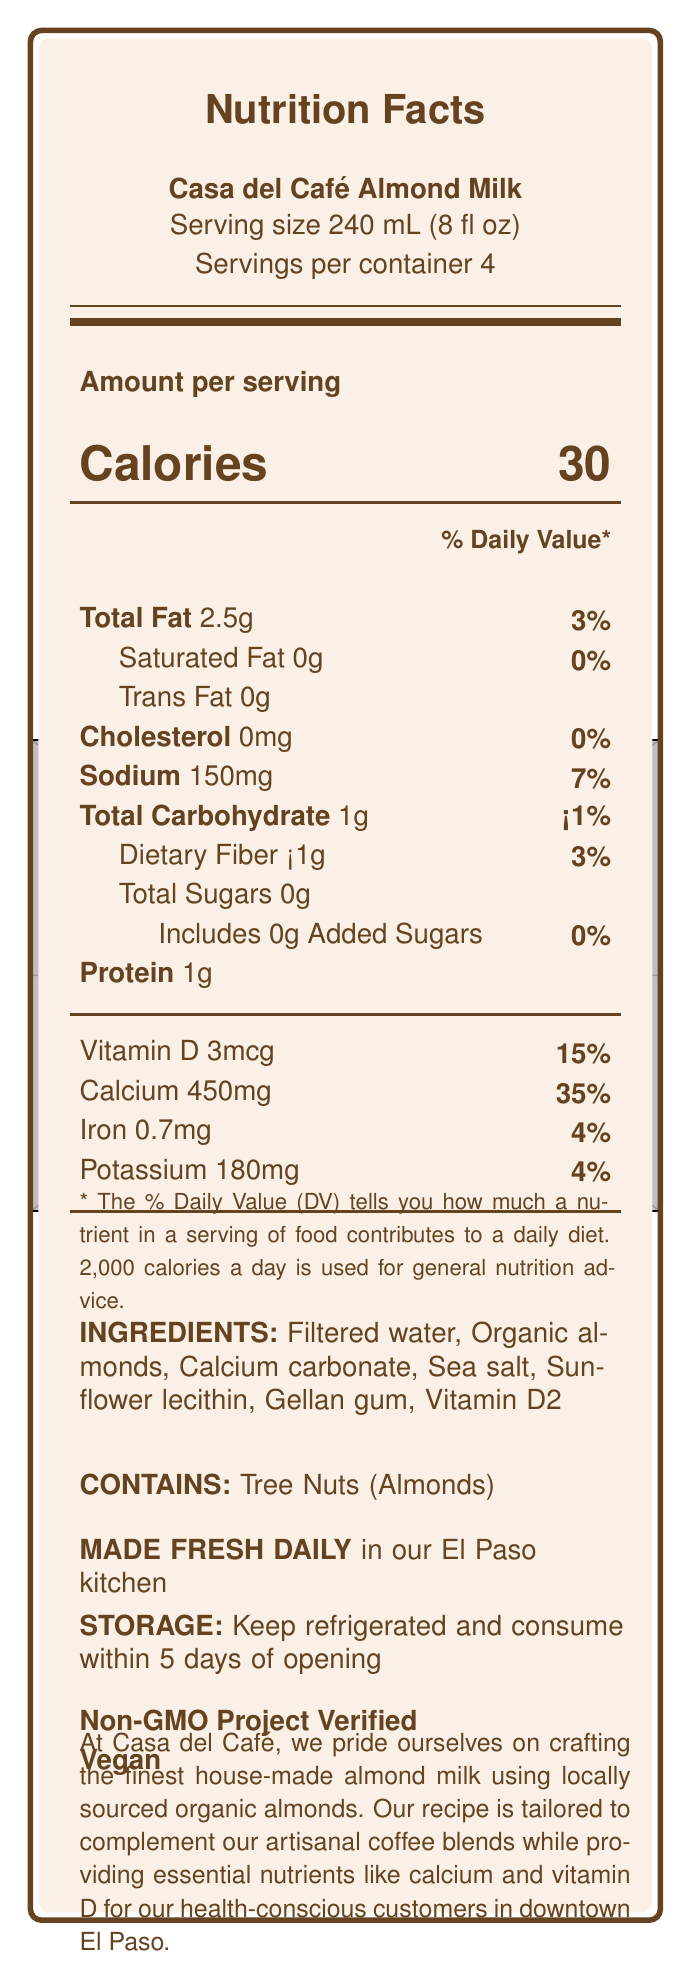who makes Casa del Café Almond Milk? The brand statement at the bottom of the document states that Casa del Café is the maker of this almond milk.
Answer: Casa del Café what is the serving size? The serving size is directly mentioned under the product name as "Serving size 240 mL (8 fl oz)".
Answer: 240 mL (8 fl oz) how many calories are in one serving? The number of calories per serving is clearly indicated across from the word "Calories" in a larger font, where it states "Calories 30".
Answer: 30 what percentage of the daily value (DV) of calcium does one serving of Casa del Café Almond Milk provide? The amount of calcium per serving is given as 450 mg, and the corresponding percentage of the daily value is listed next to it as "35%".
Answer: 35% what is the main ingredient in Casa del Café Almond Milk? The ingredients list starts with "Filtered water" followed by the other ingredients.
Answer: Filtered water how long should the almond milk be consumed after opening? The storage instructions state to keep refrigerated and consume within 5 days of opening.
Answer: Within 5 days which nutrient has the highest daily value contribution in this almond milk? A. Sodium B. Vitamin D C. Calcium D. Protein Calcium provides 35% of the daily value, which is the highest percentage listed among the nutrients.
Answer: C. Calcium how much protein does one serving of Casa del Café Almond Milk contain? The amount of protein per serving is listed at the bottom of the nutrition facts section as "Protein 1g".
Answer: 1g does Casa del Café Almond Milk contain any added sugars? The nutrition facts section specifies "Includes 0g Added Sugars", which means there are no added sugars.
Answer: No is Casa del Café Almond Milk vegan? The bottom of the label includes the certification "Vegan".
Answer: Yes summarize the main nutrients and key features of Casa del Café Almond Milk. The nutrition facts highlight the calorie count, fat, and lack of added sugars, while emphasizing the calcium and vitamin D content. Key features and certifications further underscore its health benefits and dietary suitability.
Answer: Casa del Café Almond Milk provides 30 calories per serving with 2.5g of total fat and no added sugars. It is rich in calcium (35% DV) and vitamin D (15% DV). The ingredients include filtered water, organic almonds, and several additional nutrients and stabilizers. The product is vegan and Non-GMO Project Verified. how is the almond milk prepared? The preparation method detailed in the document states that it is made fresh daily in the El Paso kitchen.
Answer: Made fresh daily in our El Paso kitchen what type of fat is absent in Casa del Café Almond Milk? The nutrition facts indicate that there is 0g of saturated fat per serving.
Answer: Saturated fat can you determine the exact price of Casa del Café Almond Milk? The document does not provide any information about the price of the product.
Answer: Not enough information 